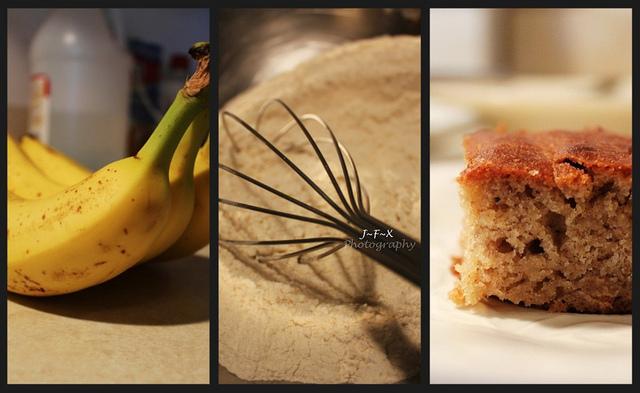Are the bananas brown?
Write a very short answer. No. How many wires does the whisk have?
Answer briefly. 10. What type of cake is that on the right image?
Give a very brief answer. Banana. 